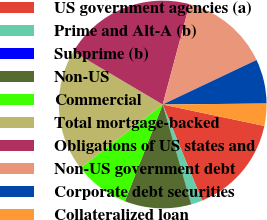Convert chart. <chart><loc_0><loc_0><loc_500><loc_500><pie_chart><fcel>US government agencies (a)<fcel>Prime and Alt-A (b)<fcel>Subprime (b)<fcel>Non-US<fcel>Commercial<fcel>Total mortgage-backed<fcel>Obligations of US states and<fcel>Non-US government debt<fcel>Corporate debt securities<fcel>Collateralized loan<nl><fcel>15.5%<fcel>1.74%<fcel>0.02%<fcel>10.34%<fcel>8.62%<fcel>18.95%<fcel>20.67%<fcel>13.78%<fcel>6.9%<fcel>3.46%<nl></chart> 